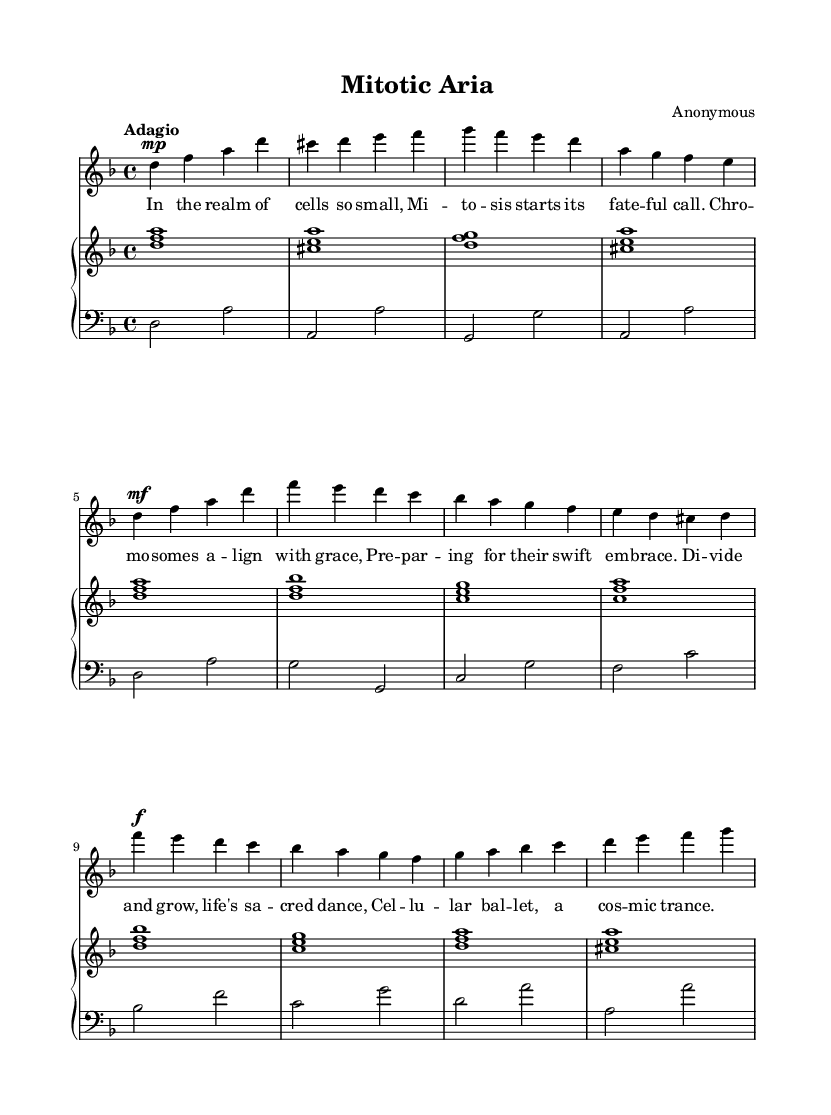What is the key signature of this music? The key signature is indicated at the beginning of the staff, showing two flats, which corresponds to D minor.
Answer: D minor What is the time signature of this piece? The time signature is represented by the numbers at the beginning of the score, showing 4 over 4.
Answer: 4/4 What is the tempo marking for this piece? The tempo is specified above the staff, written as "Adagio," which indicates a slow tempo.
Answer: Adagio How many measures are in the chorus section? The chorus is constructed with 4 measures, as evidenced by analyzing the layout where the music is divided into distinct measures.
Answer: 4 What is the dynamic marking for the beginning of the verse? The dynamic marking at the beginning of the verse indicates "mf," which stands for mezzo-forte, meaning moderately loud.
Answer: mf In which section do the lyrics discuss "mitosis"? The lyrics that mention "mitosis" are found in the "Verse 1" section since it's in that part of the written lyrics.
Answer: Verse 1 What is the vocal range indicated for the soprano part? The soprano part starts on D and reaches up to f', indicating the vocal range for the soprano is approximately from D to f'.
Answer: D to f' 